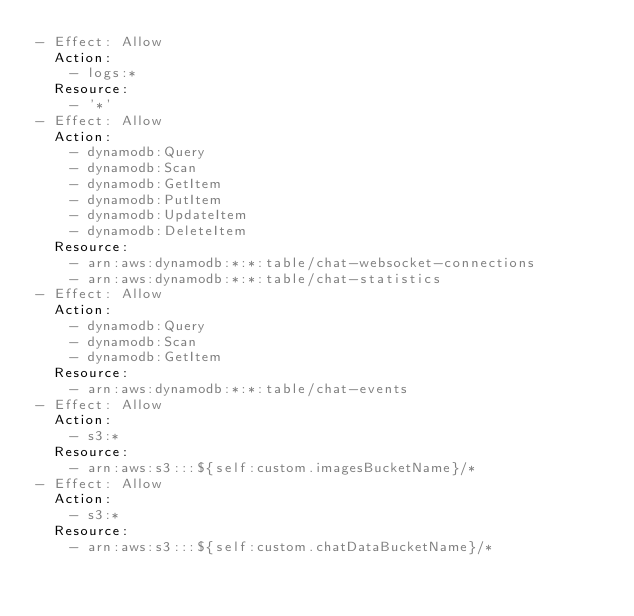<code> <loc_0><loc_0><loc_500><loc_500><_YAML_>- Effect: Allow
  Action:
    - logs:*
  Resource:
    - '*'
- Effect: Allow
  Action:
    - dynamodb:Query
    - dynamodb:Scan
    - dynamodb:GetItem
    - dynamodb:PutItem
    - dynamodb:UpdateItem
    - dynamodb:DeleteItem
  Resource:
    - arn:aws:dynamodb:*:*:table/chat-websocket-connections
    - arn:aws:dynamodb:*:*:table/chat-statistics
- Effect: Allow
  Action:
    - dynamodb:Query
    - dynamodb:Scan
    - dynamodb:GetItem
  Resource:
    - arn:aws:dynamodb:*:*:table/chat-events
- Effect: Allow
  Action:
    - s3:*
  Resource:
    - arn:aws:s3:::${self:custom.imagesBucketName}/*
- Effect: Allow
  Action:
    - s3:*
  Resource:
    - arn:aws:s3:::${self:custom.chatDataBucketName}/*
</code> 